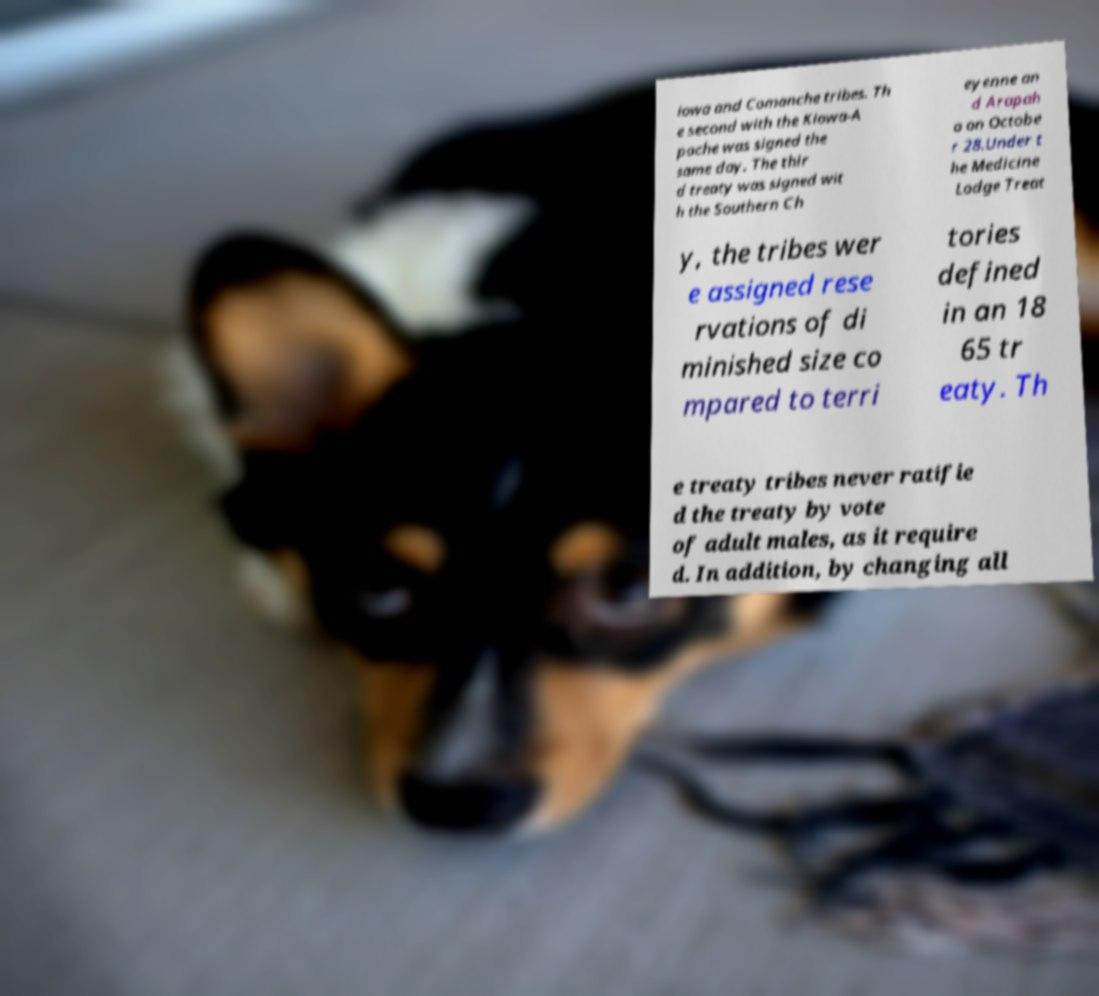Please read and relay the text visible in this image. What does it say? iowa and Comanche tribes. Th e second with the Kiowa-A pache was signed the same day. The thir d treaty was signed wit h the Southern Ch eyenne an d Arapah o on Octobe r 28.Under t he Medicine Lodge Treat y, the tribes wer e assigned rese rvations of di minished size co mpared to terri tories defined in an 18 65 tr eaty. Th e treaty tribes never ratifie d the treaty by vote of adult males, as it require d. In addition, by changing all 